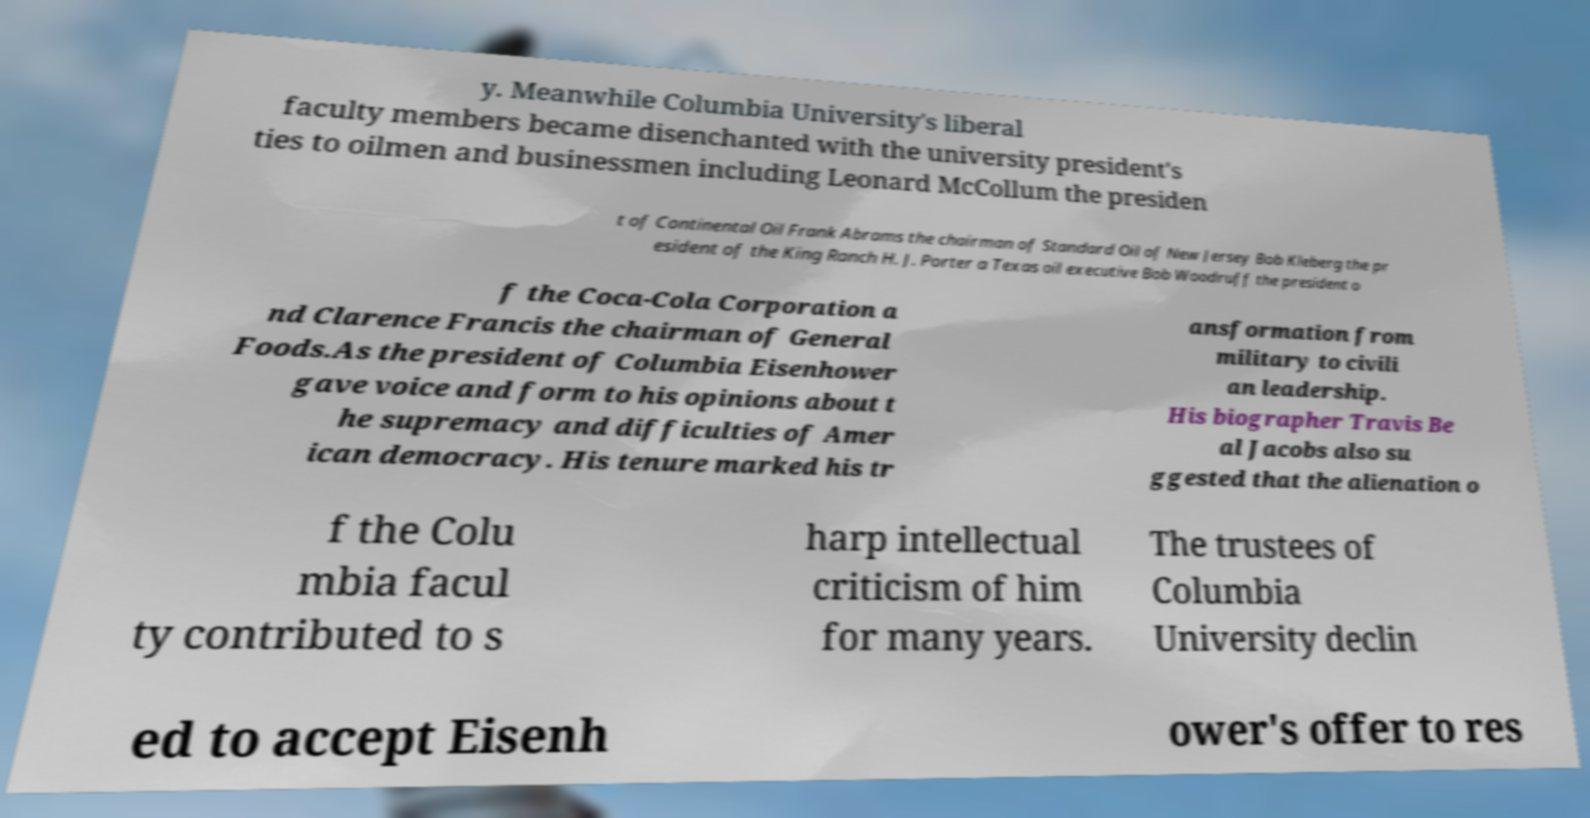Can you accurately transcribe the text from the provided image for me? y. Meanwhile Columbia University's liberal faculty members became disenchanted with the university president's ties to oilmen and businessmen including Leonard McCollum the presiden t of Continental Oil Frank Abrams the chairman of Standard Oil of New Jersey Bob Kleberg the pr esident of the King Ranch H. J. Porter a Texas oil executive Bob Woodruff the president o f the Coca-Cola Corporation a nd Clarence Francis the chairman of General Foods.As the president of Columbia Eisenhower gave voice and form to his opinions about t he supremacy and difficulties of Amer ican democracy. His tenure marked his tr ansformation from military to civili an leadership. His biographer Travis Be al Jacobs also su ggested that the alienation o f the Colu mbia facul ty contributed to s harp intellectual criticism of him for many years. The trustees of Columbia University declin ed to accept Eisenh ower's offer to res 